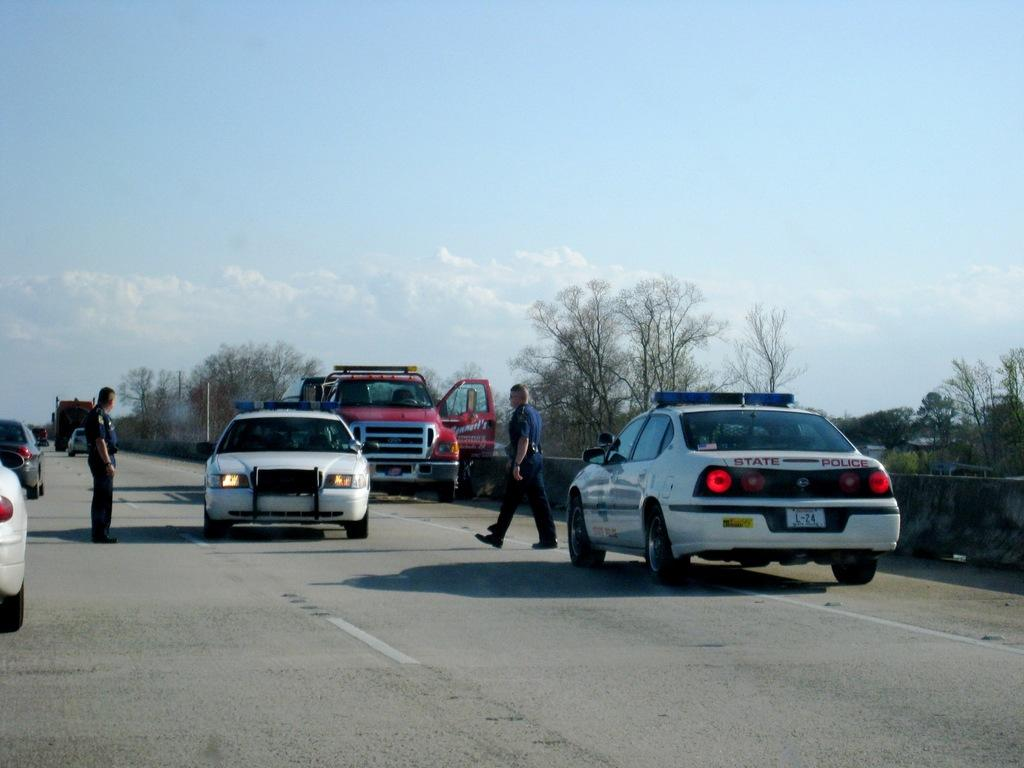What type of vehicles can be seen on the road in the image? There are cars on the road in the image. Are there any people visible in the image? Yes, two people are standing on the road in the image. What type of vegetation is on the right side of the image? There are trees on the right side of the image. What is visible at the top of the image? The sky is visible at the top of the image. What is the cause of the protest happening on the road in the image? There is no protest present in the image; it only shows cars on the road and two people standing nearby. How much blood can be seen on the road in the image? There is no blood visible in the image; it only shows cars on the road and two people standing nearby. 